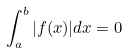Convert formula to latex. <formula><loc_0><loc_0><loc_500><loc_500>\int _ { a } ^ { b } | f ( x ) | d x = 0</formula> 